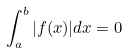Convert formula to latex. <formula><loc_0><loc_0><loc_500><loc_500>\int _ { a } ^ { b } | f ( x ) | d x = 0</formula> 